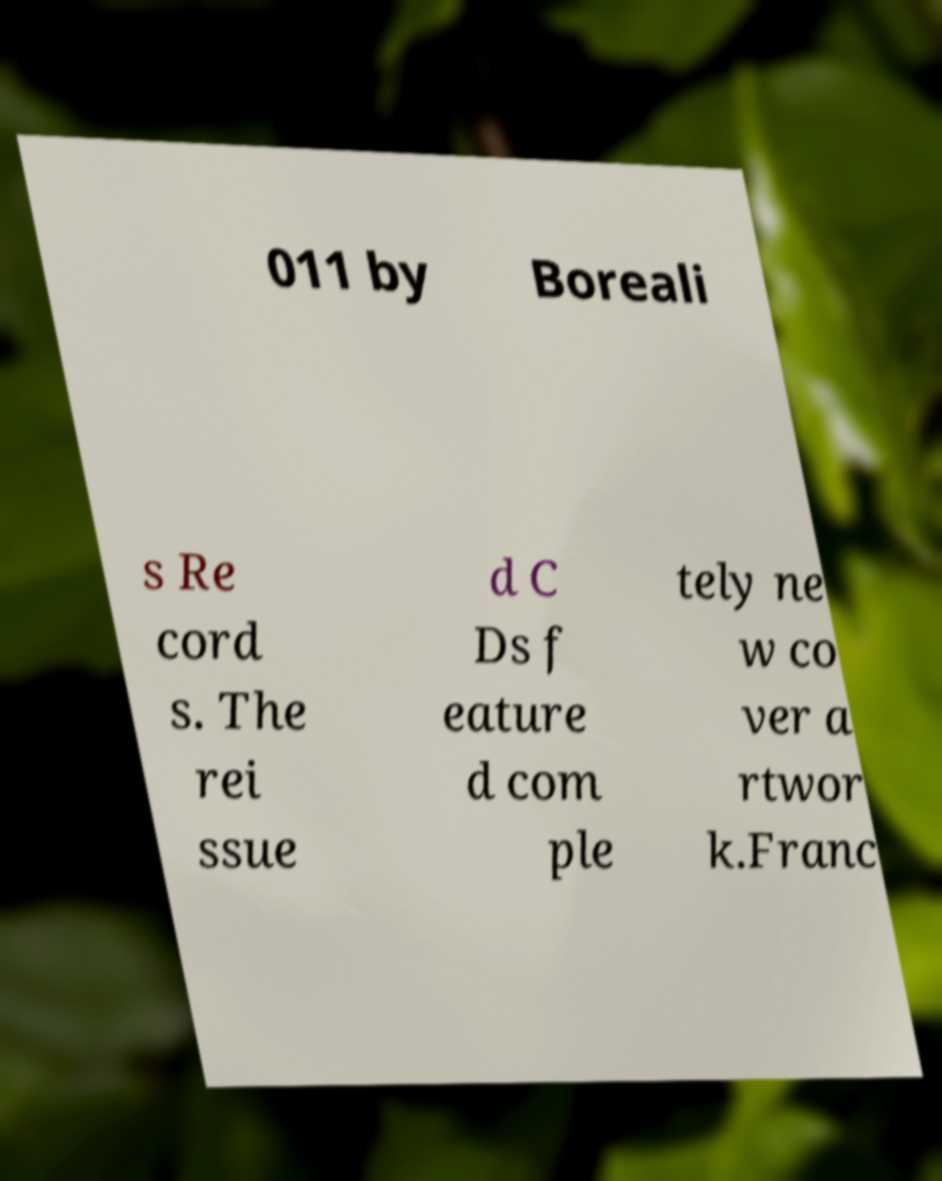Can you read and provide the text displayed in the image?This photo seems to have some interesting text. Can you extract and type it out for me? 011 by Boreali s Re cord s. The rei ssue d C Ds f eature d com ple tely ne w co ver a rtwor k.Franc 